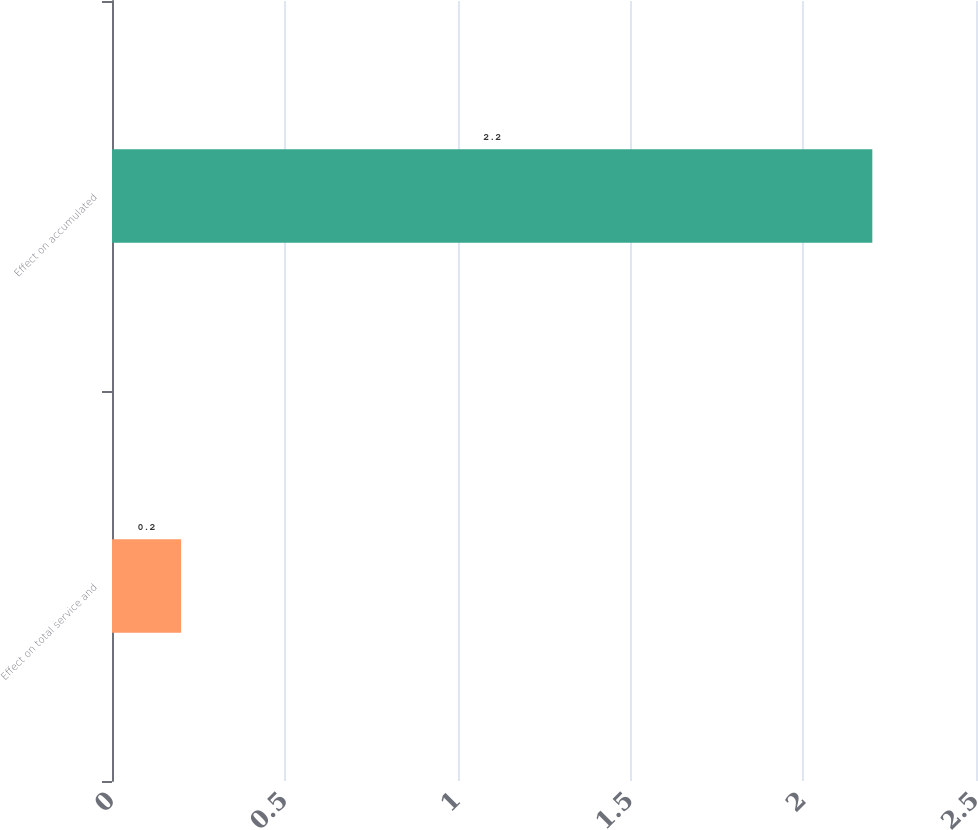Convert chart to OTSL. <chart><loc_0><loc_0><loc_500><loc_500><bar_chart><fcel>Effect on total service and<fcel>Effect on accumulated<nl><fcel>0.2<fcel>2.2<nl></chart> 